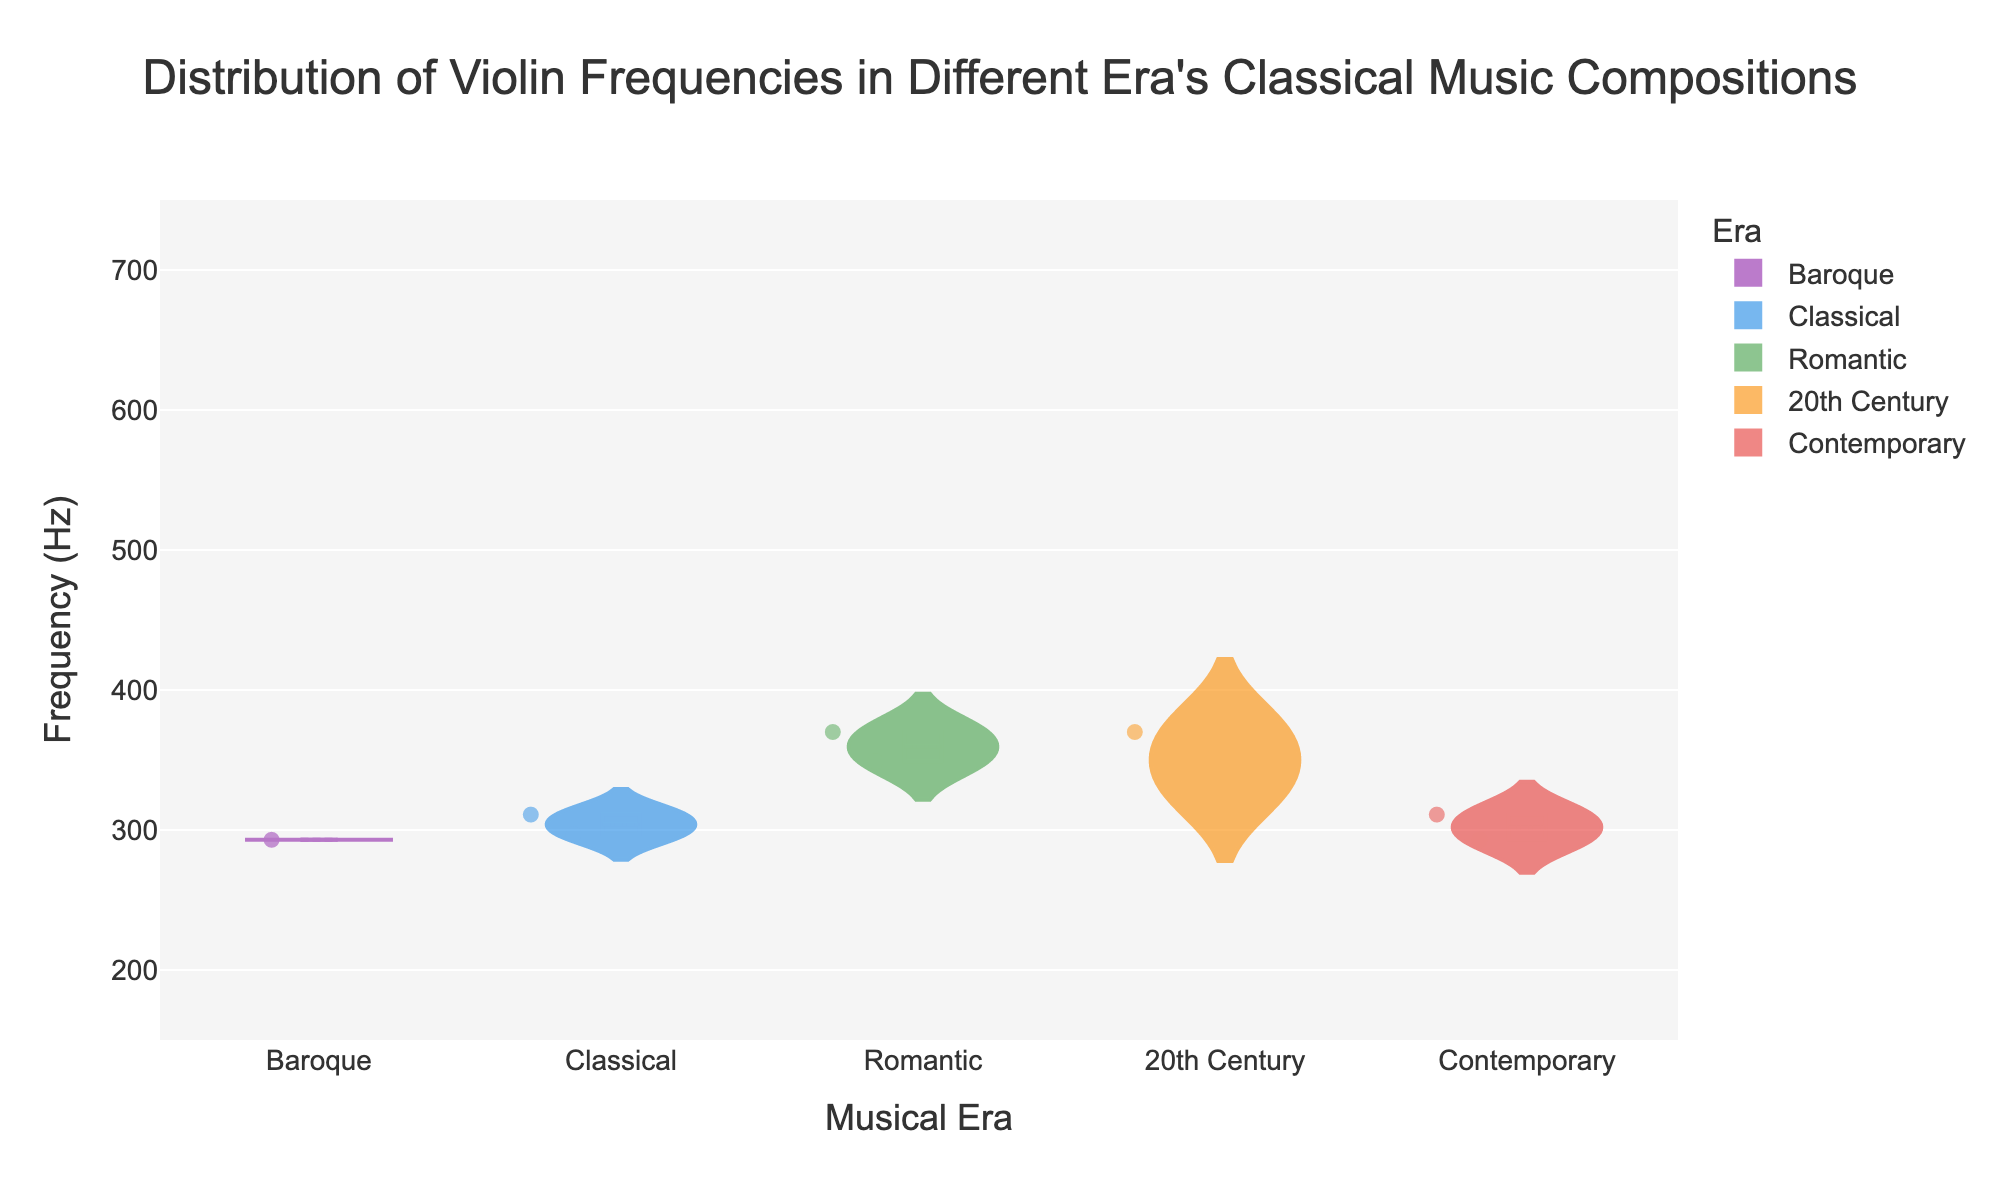Which musical era, according to the chart, has the highest median frequency for violin compositions? The chart’s y-axis represents frequency, and the median frequency is marked by a line within the violin plot. Observing the plots, the Romantic era is represented by the highest median frequency within its data spread.
Answer: Romantic What is the lower quartile frequency for violin compositions in the Baroque era? The lower quartile frequency is marked at the 25th percentile of the data in the figure. For the Baroque era, it is highlighted within the box plot overlay on the violin plot. According to the figure, the lower quartile for the Baroque era is 220 Hz.
Answer: 220 Hz How does the spread of violin frequencies in the Contemporary era compare with the Classical era in terms of interquartile range? To determine the spread, calculate the interquartile range (IQR) which is the difference between the upper and lower quartiles. In the Contemporary era, the upper quartile is 415 Hz, and the lower quartile is 220 Hz, giving an IQR of 195 Hz. For the Classical era, the upper quartile is 392 Hz and the lower quartile is 247 Hz, resulting in an IQR of 145 Hz.
Answer: Contemporary era has a wider IQR In which era do violin compositions exhibit the widest range of frequencies? The range is determined by the difference between the maximum and minimum values. Observing the chart, the Romantic era exhibits the widest range as the maximum frequency is 698 Hz and the minimum is 233 Hz, resulting in a range of 465 Hz.
Answer: Romantic Which era has the smallest variability in violin frequencies based on the interquartile range (IQR)? Variability can be assessed by comparing the IQR for each era. To do this, subtract the lower quartile from the upper quartile for each era. Observing the violin plots, the Baroque era has the IQR calculated by subtracting the lower quartile (220 Hz) from the upper quartile (349 Hz), yielding an IQR of 129 Hz, which is the smallest IQR among all eras.
Answer: Baroque What is the maximum frequency for violin compositions in the 20th Century era as shown in the chart? The maximum frequency is indicated by the highest value at the top of each violin plot. Looking at the 20th Century era, the visual chart shows a maximum at 659 Hz.
Answer: 659 Hz Between the Classical and Romantic eras, which one has a higher median frequency and by how much? Identify the median frequencies from the charts of the Classical and Romantic eras. The Classical era has a median frequency of approximately 311 Hz, while the Romantic era's median is around 370 Hz. The difference between these median frequencies is 370 Hz - 311 Hz = 59 Hz, indicating that the Romantic era has a higher median frequency.
Answer: Romantic by 59 Hz How many musical eras are represented in the violin chart? The x-axis of the violin chart represents the different musical eras. Count the number of distinct eras displayed along the x-axis. There are five distinct eras: Baroque, Classical, Romantic, 20th Century, and Contemporary.
Answer: 5 eras 